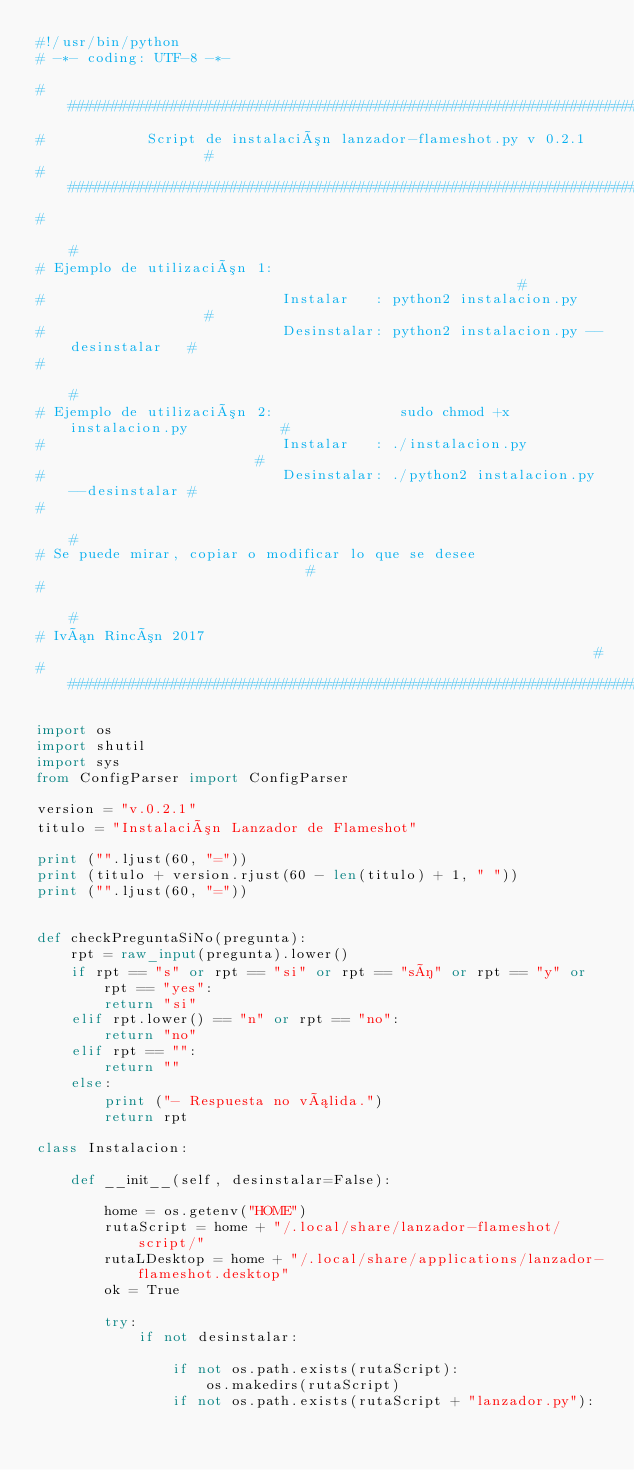Convert code to text. <code><loc_0><loc_0><loc_500><loc_500><_Python_>#!/usr/bin/python
# -*- coding: UTF-8 -*-
 
##################################################################################
#            Script de instalación lanzador-flameshot.py v 0.2.1                 #
##################################################################################
#                                                                                #
# Ejemplo de utilización 1:                                                      #
#                            Instalar   : python2 instalacion.py                 #
#                            Desinstalar: python2 instalacion.py --desinstalar   #
#                                                                                #
# Ejemplo de utilización 2:               sudo chmod +x instalacion.py           #
#                            Instalar   : ./instalacion.py                       #
#                            Desinstalar: ./python2 instalacion.py --desinstalar #
#                                                                                #
# Se puede mirar, copiar o modificar lo que se desee                             #
#                                                                                #
# Iván Rincón 2017                                                               #
##################################################################################
 
import os
import shutil
import sys
from ConfigParser import ConfigParser

version = "v.0.2.1"
titulo = "Instalación Lanzador de Flameshot"
 
print ("".ljust(60, "="))
print (titulo + version.rjust(60 - len(titulo) + 1, " "))
print ("".ljust(60, "="))
 
 
def checkPreguntaSiNo(pregunta):
    rpt = raw_input(pregunta).lower()
    if rpt == "s" or rpt == "si" or rpt == "sí" or rpt == "y" or rpt == "yes":
        return "si"
    elif rpt.lower() == "n" or rpt == "no":
        return "no"
    elif rpt == "":
        return ""
    else:
        print ("- Respuesta no válida.")
        return rpt
 
class Instalacion:
 
    def __init__(self, desinstalar=False):
 
        home = os.getenv("HOME")
        rutaScript = home + "/.local/share/lanzador-flameshot/script/"
        rutaLDesktop = home + "/.local/share/applications/lanzador-flameshot.desktop"
        ok = True
 
        try:
            if not desinstalar:
 
                if not os.path.exists(rutaScript):
                    os.makedirs(rutaScript)
                if not os.path.exists(rutaScript + "lanzador.py"):</code> 